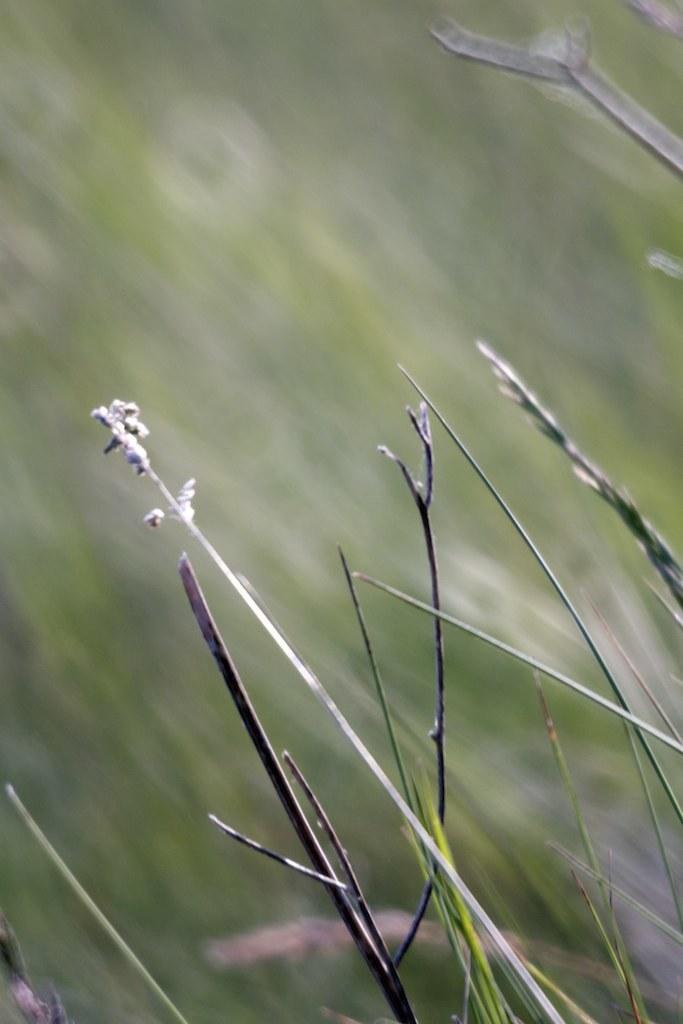Please provide a concise description of this image. In this image I can see few plants and the blurry background. 